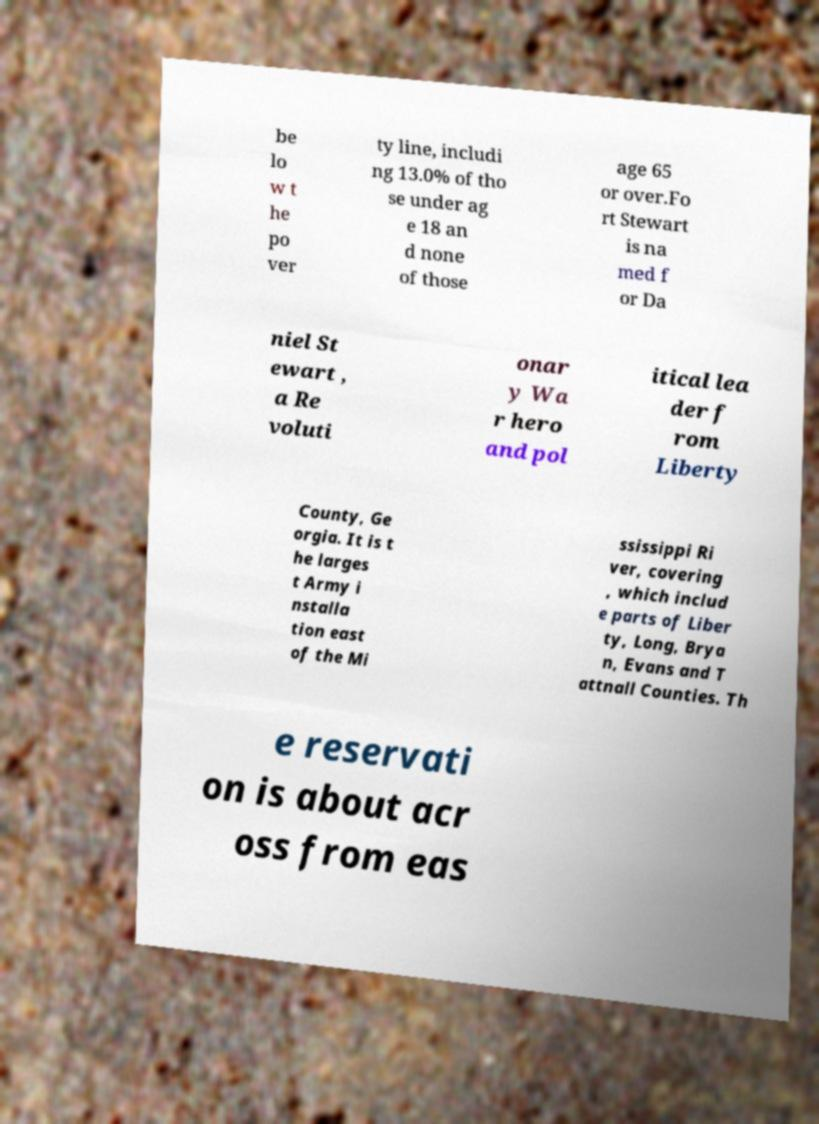What messages or text are displayed in this image? I need them in a readable, typed format. be lo w t he po ver ty line, includi ng 13.0% of tho se under ag e 18 an d none of those age 65 or over.Fo rt Stewart is na med f or Da niel St ewart , a Re voluti onar y Wa r hero and pol itical lea der f rom Liberty County, Ge orgia. It is t he larges t Army i nstalla tion east of the Mi ssissippi Ri ver, covering , which includ e parts of Liber ty, Long, Brya n, Evans and T attnall Counties. Th e reservati on is about acr oss from eas 